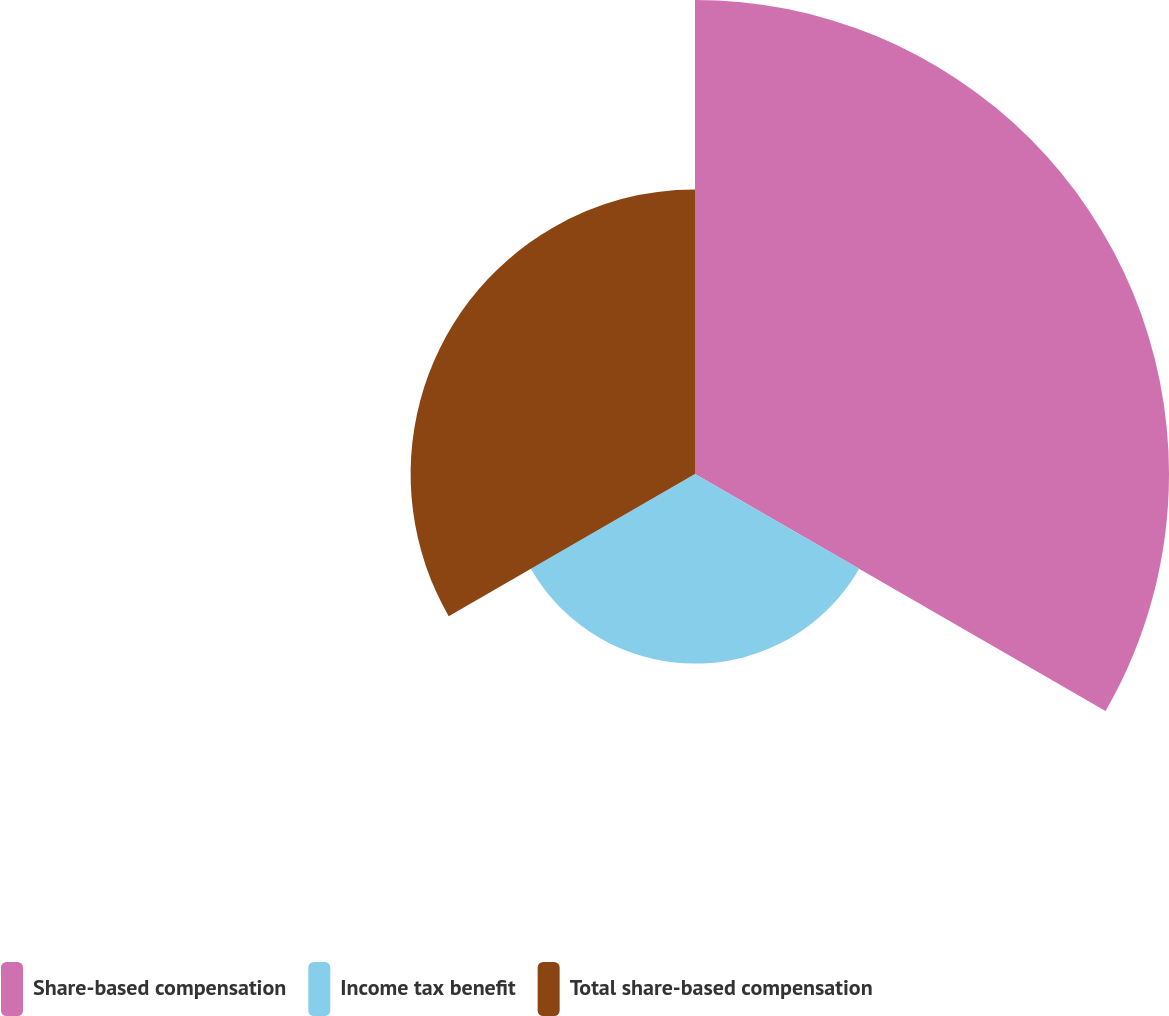Convert chart to OTSL. <chart><loc_0><loc_0><loc_500><loc_500><pie_chart><fcel>Share-based compensation<fcel>Income tax benefit<fcel>Total share-based compensation<nl><fcel>50.0%<fcel>20.0%<fcel>30.0%<nl></chart> 